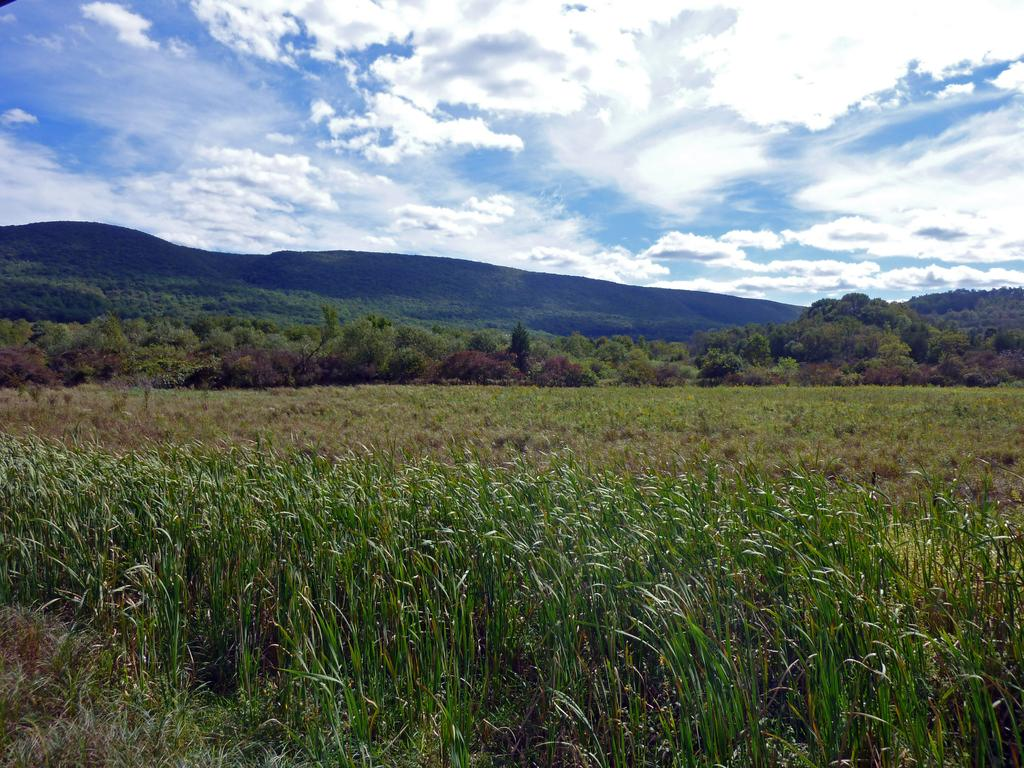What type of vegetation can be seen in the image? There is grass in the image. What other natural elements are present in the image? There are trees in the image. What can be seen in the background of the image? There is a mountain in the background of the image. What is visible in the sky in the image? Clouds are present in the sky. What type of dress is the word wearing in the image? There is no dress or word present in the image; it features natural elements such as grass, trees, a mountain, and clouds. 